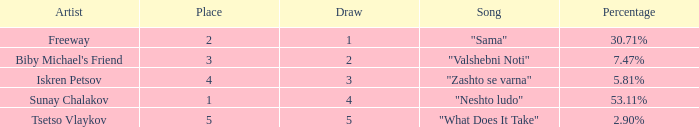Parse the table in full. {'header': ['Artist', 'Place', 'Draw', 'Song', 'Percentage'], 'rows': [['Freeway', '2', '1', '"Sama"', '30.71%'], ["Biby Michael's Friend", '3', '2', '"Valshebni Noti"', '7.47%'], ['Iskren Petsov', '4', '3', '"Zashto se varna"', '5.81%'], ['Sunay Chalakov', '1', '4', '"Neshto ludo"', '53.11%'], ['Tsetso Vlaykov', '5', '5', '"What Does It Take"', '2.90%']]} What is the highest draw when the place is less than 3 and the percentage is 30.71%? 1.0. 